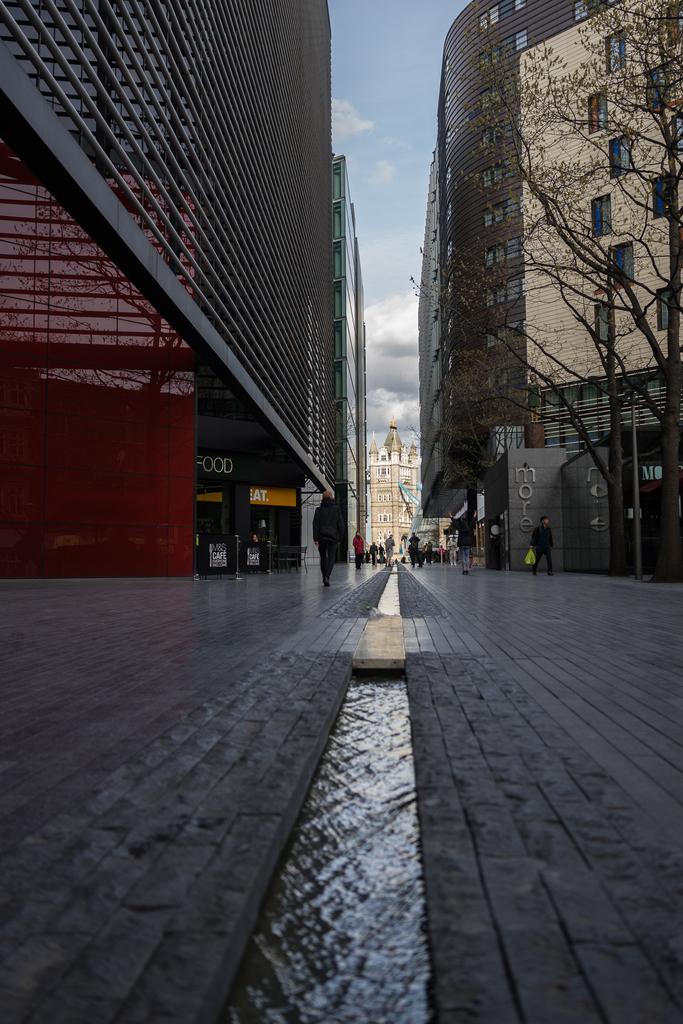What does the grey brick say?
Offer a terse response. More. What can you buy on this street?
Your answer should be very brief. Food. 